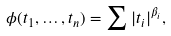Convert formula to latex. <formula><loc_0><loc_0><loc_500><loc_500>\phi ( t _ { 1 } , \dots , t _ { n } ) = \sum | t _ { i } | ^ { \beta _ { i } } ,</formula> 